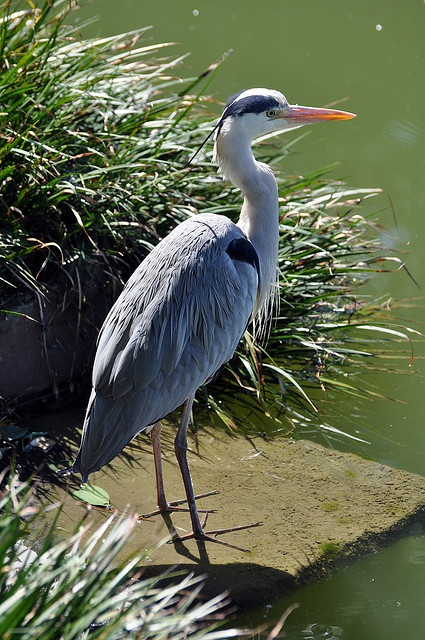Describe the objects in this image and their specific colors. I can see a bird in gray, black, navy, and lightgray tones in this image. 